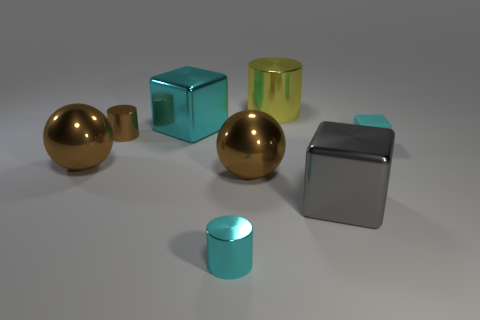There is a cyan cube behind the matte object; what material is it?
Offer a very short reply. Metal. Are there any other things that are the same size as the cyan metallic cube?
Ensure brevity in your answer.  Yes. Is the number of big brown metal spheres less than the number of tiny green cylinders?
Your response must be concise. No. There is a small object that is to the left of the large gray block and in front of the brown shiny cylinder; what is its shape?
Your answer should be compact. Cylinder. What number of small brown shiny objects are there?
Your answer should be compact. 1. There is a small cyan object in front of the big brown thing left of the big cyan metal thing that is on the left side of the small cyan matte cube; what is it made of?
Your answer should be very brief. Metal. What number of big brown metal balls are on the left side of the small shiny cylinder that is on the left side of the large cyan block?
Give a very brief answer. 1. What color is the small rubber object that is the same shape as the large cyan metallic object?
Offer a very short reply. Cyan. Do the small cyan cylinder and the small block have the same material?
Keep it short and to the point. No. How many balls are either tiny cyan shiny things or small brown things?
Offer a very short reply. 0. 